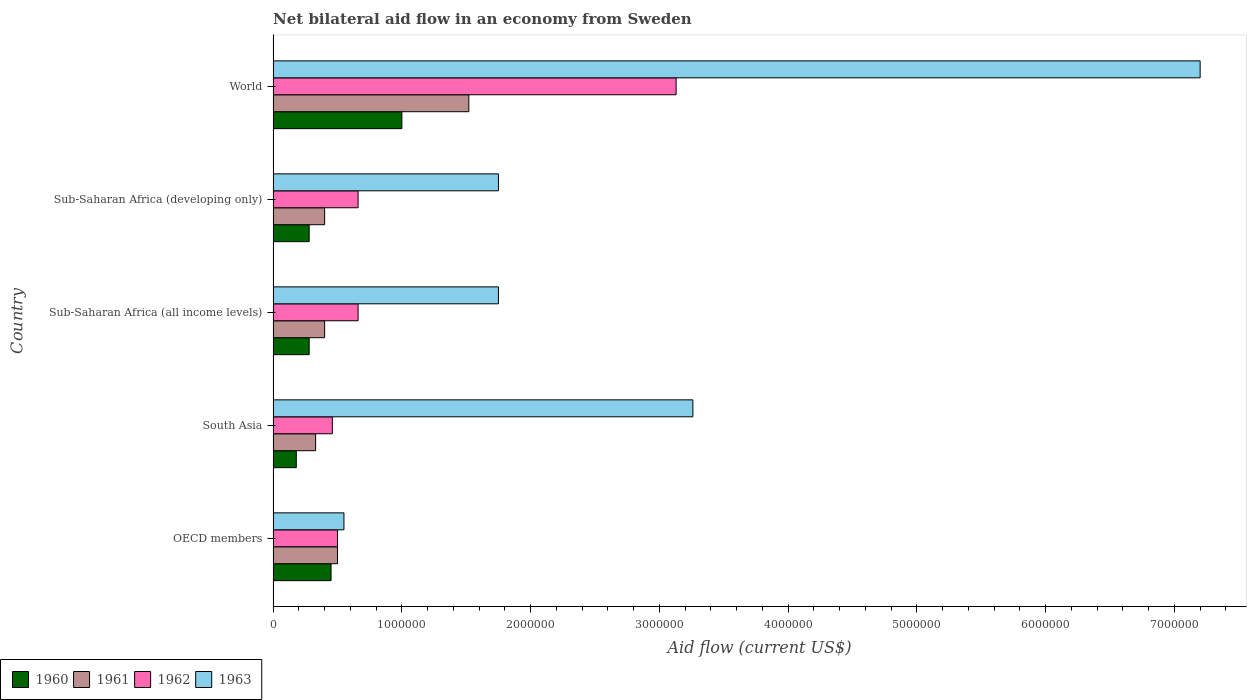How many bars are there on the 1st tick from the bottom?
Ensure brevity in your answer.  4. What is the net bilateral aid flow in 1960 in World?
Give a very brief answer. 1.00e+06. What is the total net bilateral aid flow in 1961 in the graph?
Your response must be concise. 3.15e+06. What is the difference between the net bilateral aid flow in 1962 in Sub-Saharan Africa (all income levels) and that in World?
Your answer should be compact. -2.47e+06. What is the difference between the net bilateral aid flow in 1962 in Sub-Saharan Africa (all income levels) and the net bilateral aid flow in 1963 in OECD members?
Your answer should be very brief. 1.10e+05. What is the average net bilateral aid flow in 1962 per country?
Give a very brief answer. 1.08e+06. What is the difference between the net bilateral aid flow in 1962 and net bilateral aid flow in 1960 in World?
Provide a succinct answer. 2.13e+06. In how many countries, is the net bilateral aid flow in 1962 greater than 7200000 US$?
Your response must be concise. 0. What is the ratio of the net bilateral aid flow in 1961 in South Asia to that in Sub-Saharan Africa (all income levels)?
Ensure brevity in your answer.  0.82. Is the net bilateral aid flow in 1961 in Sub-Saharan Africa (all income levels) less than that in Sub-Saharan Africa (developing only)?
Your answer should be compact. No. What is the difference between the highest and the second highest net bilateral aid flow in 1963?
Your response must be concise. 3.94e+06. What is the difference between the highest and the lowest net bilateral aid flow in 1960?
Ensure brevity in your answer.  8.20e+05. In how many countries, is the net bilateral aid flow in 1963 greater than the average net bilateral aid flow in 1963 taken over all countries?
Your answer should be very brief. 2. Is the sum of the net bilateral aid flow in 1961 in Sub-Saharan Africa (all income levels) and Sub-Saharan Africa (developing only) greater than the maximum net bilateral aid flow in 1962 across all countries?
Your answer should be compact. No. Is it the case that in every country, the sum of the net bilateral aid flow in 1961 and net bilateral aid flow in 1960 is greater than the net bilateral aid flow in 1963?
Provide a short and direct response. No. How many bars are there?
Keep it short and to the point. 20. What is the difference between two consecutive major ticks on the X-axis?
Make the answer very short. 1.00e+06. Are the values on the major ticks of X-axis written in scientific E-notation?
Offer a terse response. No. Does the graph contain any zero values?
Your response must be concise. No. Does the graph contain grids?
Provide a succinct answer. No. Where does the legend appear in the graph?
Your answer should be very brief. Bottom left. How many legend labels are there?
Keep it short and to the point. 4. What is the title of the graph?
Ensure brevity in your answer.  Net bilateral aid flow in an economy from Sweden. What is the Aid flow (current US$) in 1961 in OECD members?
Offer a terse response. 5.00e+05. What is the Aid flow (current US$) in 1962 in OECD members?
Make the answer very short. 5.00e+05. What is the Aid flow (current US$) in 1963 in South Asia?
Make the answer very short. 3.26e+06. What is the Aid flow (current US$) of 1960 in Sub-Saharan Africa (all income levels)?
Offer a very short reply. 2.80e+05. What is the Aid flow (current US$) in 1961 in Sub-Saharan Africa (all income levels)?
Ensure brevity in your answer.  4.00e+05. What is the Aid flow (current US$) in 1962 in Sub-Saharan Africa (all income levels)?
Make the answer very short. 6.60e+05. What is the Aid flow (current US$) of 1963 in Sub-Saharan Africa (all income levels)?
Make the answer very short. 1.75e+06. What is the Aid flow (current US$) of 1961 in Sub-Saharan Africa (developing only)?
Offer a very short reply. 4.00e+05. What is the Aid flow (current US$) of 1963 in Sub-Saharan Africa (developing only)?
Keep it short and to the point. 1.75e+06. What is the Aid flow (current US$) of 1961 in World?
Your answer should be very brief. 1.52e+06. What is the Aid flow (current US$) in 1962 in World?
Your answer should be compact. 3.13e+06. What is the Aid flow (current US$) in 1963 in World?
Offer a terse response. 7.20e+06. Across all countries, what is the maximum Aid flow (current US$) in 1961?
Your answer should be compact. 1.52e+06. Across all countries, what is the maximum Aid flow (current US$) of 1962?
Make the answer very short. 3.13e+06. Across all countries, what is the maximum Aid flow (current US$) of 1963?
Offer a terse response. 7.20e+06. Across all countries, what is the minimum Aid flow (current US$) in 1961?
Ensure brevity in your answer.  3.30e+05. Across all countries, what is the minimum Aid flow (current US$) of 1962?
Offer a very short reply. 4.60e+05. What is the total Aid flow (current US$) in 1960 in the graph?
Make the answer very short. 2.19e+06. What is the total Aid flow (current US$) in 1961 in the graph?
Provide a short and direct response. 3.15e+06. What is the total Aid flow (current US$) in 1962 in the graph?
Your answer should be very brief. 5.41e+06. What is the total Aid flow (current US$) in 1963 in the graph?
Make the answer very short. 1.45e+07. What is the difference between the Aid flow (current US$) of 1960 in OECD members and that in South Asia?
Your answer should be compact. 2.70e+05. What is the difference between the Aid flow (current US$) in 1963 in OECD members and that in South Asia?
Your answer should be compact. -2.71e+06. What is the difference between the Aid flow (current US$) in 1960 in OECD members and that in Sub-Saharan Africa (all income levels)?
Your answer should be compact. 1.70e+05. What is the difference between the Aid flow (current US$) of 1961 in OECD members and that in Sub-Saharan Africa (all income levels)?
Offer a very short reply. 1.00e+05. What is the difference between the Aid flow (current US$) in 1962 in OECD members and that in Sub-Saharan Africa (all income levels)?
Offer a very short reply. -1.60e+05. What is the difference between the Aid flow (current US$) of 1963 in OECD members and that in Sub-Saharan Africa (all income levels)?
Make the answer very short. -1.20e+06. What is the difference between the Aid flow (current US$) in 1963 in OECD members and that in Sub-Saharan Africa (developing only)?
Ensure brevity in your answer.  -1.20e+06. What is the difference between the Aid flow (current US$) in 1960 in OECD members and that in World?
Ensure brevity in your answer.  -5.50e+05. What is the difference between the Aid flow (current US$) in 1961 in OECD members and that in World?
Your answer should be very brief. -1.02e+06. What is the difference between the Aid flow (current US$) of 1962 in OECD members and that in World?
Your answer should be very brief. -2.63e+06. What is the difference between the Aid flow (current US$) in 1963 in OECD members and that in World?
Provide a succinct answer. -6.65e+06. What is the difference between the Aid flow (current US$) in 1960 in South Asia and that in Sub-Saharan Africa (all income levels)?
Provide a succinct answer. -1.00e+05. What is the difference between the Aid flow (current US$) of 1962 in South Asia and that in Sub-Saharan Africa (all income levels)?
Keep it short and to the point. -2.00e+05. What is the difference between the Aid flow (current US$) of 1963 in South Asia and that in Sub-Saharan Africa (all income levels)?
Offer a very short reply. 1.51e+06. What is the difference between the Aid flow (current US$) of 1962 in South Asia and that in Sub-Saharan Africa (developing only)?
Ensure brevity in your answer.  -2.00e+05. What is the difference between the Aid flow (current US$) in 1963 in South Asia and that in Sub-Saharan Africa (developing only)?
Ensure brevity in your answer.  1.51e+06. What is the difference between the Aid flow (current US$) in 1960 in South Asia and that in World?
Your answer should be compact. -8.20e+05. What is the difference between the Aid flow (current US$) of 1961 in South Asia and that in World?
Your answer should be compact. -1.19e+06. What is the difference between the Aid flow (current US$) in 1962 in South Asia and that in World?
Your answer should be very brief. -2.67e+06. What is the difference between the Aid flow (current US$) of 1963 in South Asia and that in World?
Offer a terse response. -3.94e+06. What is the difference between the Aid flow (current US$) in 1961 in Sub-Saharan Africa (all income levels) and that in Sub-Saharan Africa (developing only)?
Keep it short and to the point. 0. What is the difference between the Aid flow (current US$) of 1960 in Sub-Saharan Africa (all income levels) and that in World?
Your response must be concise. -7.20e+05. What is the difference between the Aid flow (current US$) in 1961 in Sub-Saharan Africa (all income levels) and that in World?
Provide a succinct answer. -1.12e+06. What is the difference between the Aid flow (current US$) of 1962 in Sub-Saharan Africa (all income levels) and that in World?
Make the answer very short. -2.47e+06. What is the difference between the Aid flow (current US$) of 1963 in Sub-Saharan Africa (all income levels) and that in World?
Your response must be concise. -5.45e+06. What is the difference between the Aid flow (current US$) of 1960 in Sub-Saharan Africa (developing only) and that in World?
Provide a short and direct response. -7.20e+05. What is the difference between the Aid flow (current US$) of 1961 in Sub-Saharan Africa (developing only) and that in World?
Give a very brief answer. -1.12e+06. What is the difference between the Aid flow (current US$) in 1962 in Sub-Saharan Africa (developing only) and that in World?
Provide a succinct answer. -2.47e+06. What is the difference between the Aid flow (current US$) of 1963 in Sub-Saharan Africa (developing only) and that in World?
Provide a short and direct response. -5.45e+06. What is the difference between the Aid flow (current US$) of 1960 in OECD members and the Aid flow (current US$) of 1963 in South Asia?
Ensure brevity in your answer.  -2.81e+06. What is the difference between the Aid flow (current US$) of 1961 in OECD members and the Aid flow (current US$) of 1962 in South Asia?
Keep it short and to the point. 4.00e+04. What is the difference between the Aid flow (current US$) in 1961 in OECD members and the Aid flow (current US$) in 1963 in South Asia?
Give a very brief answer. -2.76e+06. What is the difference between the Aid flow (current US$) in 1962 in OECD members and the Aid flow (current US$) in 1963 in South Asia?
Your answer should be compact. -2.76e+06. What is the difference between the Aid flow (current US$) of 1960 in OECD members and the Aid flow (current US$) of 1961 in Sub-Saharan Africa (all income levels)?
Your answer should be compact. 5.00e+04. What is the difference between the Aid flow (current US$) in 1960 in OECD members and the Aid flow (current US$) in 1962 in Sub-Saharan Africa (all income levels)?
Give a very brief answer. -2.10e+05. What is the difference between the Aid flow (current US$) in 1960 in OECD members and the Aid flow (current US$) in 1963 in Sub-Saharan Africa (all income levels)?
Your answer should be compact. -1.30e+06. What is the difference between the Aid flow (current US$) in 1961 in OECD members and the Aid flow (current US$) in 1963 in Sub-Saharan Africa (all income levels)?
Your answer should be very brief. -1.25e+06. What is the difference between the Aid flow (current US$) in 1962 in OECD members and the Aid flow (current US$) in 1963 in Sub-Saharan Africa (all income levels)?
Your answer should be very brief. -1.25e+06. What is the difference between the Aid flow (current US$) of 1960 in OECD members and the Aid flow (current US$) of 1963 in Sub-Saharan Africa (developing only)?
Keep it short and to the point. -1.30e+06. What is the difference between the Aid flow (current US$) in 1961 in OECD members and the Aid flow (current US$) in 1962 in Sub-Saharan Africa (developing only)?
Provide a short and direct response. -1.60e+05. What is the difference between the Aid flow (current US$) in 1961 in OECD members and the Aid flow (current US$) in 1963 in Sub-Saharan Africa (developing only)?
Make the answer very short. -1.25e+06. What is the difference between the Aid flow (current US$) of 1962 in OECD members and the Aid flow (current US$) of 1963 in Sub-Saharan Africa (developing only)?
Ensure brevity in your answer.  -1.25e+06. What is the difference between the Aid flow (current US$) in 1960 in OECD members and the Aid flow (current US$) in 1961 in World?
Your answer should be compact. -1.07e+06. What is the difference between the Aid flow (current US$) of 1960 in OECD members and the Aid flow (current US$) of 1962 in World?
Offer a terse response. -2.68e+06. What is the difference between the Aid flow (current US$) of 1960 in OECD members and the Aid flow (current US$) of 1963 in World?
Give a very brief answer. -6.75e+06. What is the difference between the Aid flow (current US$) in 1961 in OECD members and the Aid flow (current US$) in 1962 in World?
Keep it short and to the point. -2.63e+06. What is the difference between the Aid flow (current US$) of 1961 in OECD members and the Aid flow (current US$) of 1963 in World?
Ensure brevity in your answer.  -6.70e+06. What is the difference between the Aid flow (current US$) of 1962 in OECD members and the Aid flow (current US$) of 1963 in World?
Your response must be concise. -6.70e+06. What is the difference between the Aid flow (current US$) of 1960 in South Asia and the Aid flow (current US$) of 1962 in Sub-Saharan Africa (all income levels)?
Provide a succinct answer. -4.80e+05. What is the difference between the Aid flow (current US$) of 1960 in South Asia and the Aid flow (current US$) of 1963 in Sub-Saharan Africa (all income levels)?
Your answer should be very brief. -1.57e+06. What is the difference between the Aid flow (current US$) in 1961 in South Asia and the Aid flow (current US$) in 1962 in Sub-Saharan Africa (all income levels)?
Provide a succinct answer. -3.30e+05. What is the difference between the Aid flow (current US$) of 1961 in South Asia and the Aid flow (current US$) of 1963 in Sub-Saharan Africa (all income levels)?
Your answer should be very brief. -1.42e+06. What is the difference between the Aid flow (current US$) in 1962 in South Asia and the Aid flow (current US$) in 1963 in Sub-Saharan Africa (all income levels)?
Offer a terse response. -1.29e+06. What is the difference between the Aid flow (current US$) of 1960 in South Asia and the Aid flow (current US$) of 1962 in Sub-Saharan Africa (developing only)?
Offer a very short reply. -4.80e+05. What is the difference between the Aid flow (current US$) of 1960 in South Asia and the Aid flow (current US$) of 1963 in Sub-Saharan Africa (developing only)?
Ensure brevity in your answer.  -1.57e+06. What is the difference between the Aid flow (current US$) of 1961 in South Asia and the Aid flow (current US$) of 1962 in Sub-Saharan Africa (developing only)?
Provide a succinct answer. -3.30e+05. What is the difference between the Aid flow (current US$) of 1961 in South Asia and the Aid flow (current US$) of 1963 in Sub-Saharan Africa (developing only)?
Offer a terse response. -1.42e+06. What is the difference between the Aid flow (current US$) in 1962 in South Asia and the Aid flow (current US$) in 1963 in Sub-Saharan Africa (developing only)?
Provide a short and direct response. -1.29e+06. What is the difference between the Aid flow (current US$) in 1960 in South Asia and the Aid flow (current US$) in 1961 in World?
Ensure brevity in your answer.  -1.34e+06. What is the difference between the Aid flow (current US$) in 1960 in South Asia and the Aid flow (current US$) in 1962 in World?
Offer a very short reply. -2.95e+06. What is the difference between the Aid flow (current US$) of 1960 in South Asia and the Aid flow (current US$) of 1963 in World?
Offer a terse response. -7.02e+06. What is the difference between the Aid flow (current US$) in 1961 in South Asia and the Aid flow (current US$) in 1962 in World?
Your answer should be compact. -2.80e+06. What is the difference between the Aid flow (current US$) in 1961 in South Asia and the Aid flow (current US$) in 1963 in World?
Ensure brevity in your answer.  -6.87e+06. What is the difference between the Aid flow (current US$) in 1962 in South Asia and the Aid flow (current US$) in 1963 in World?
Your response must be concise. -6.74e+06. What is the difference between the Aid flow (current US$) in 1960 in Sub-Saharan Africa (all income levels) and the Aid flow (current US$) in 1961 in Sub-Saharan Africa (developing only)?
Offer a terse response. -1.20e+05. What is the difference between the Aid flow (current US$) of 1960 in Sub-Saharan Africa (all income levels) and the Aid flow (current US$) of 1962 in Sub-Saharan Africa (developing only)?
Your answer should be very brief. -3.80e+05. What is the difference between the Aid flow (current US$) of 1960 in Sub-Saharan Africa (all income levels) and the Aid flow (current US$) of 1963 in Sub-Saharan Africa (developing only)?
Your response must be concise. -1.47e+06. What is the difference between the Aid flow (current US$) of 1961 in Sub-Saharan Africa (all income levels) and the Aid flow (current US$) of 1963 in Sub-Saharan Africa (developing only)?
Provide a succinct answer. -1.35e+06. What is the difference between the Aid flow (current US$) in 1962 in Sub-Saharan Africa (all income levels) and the Aid flow (current US$) in 1963 in Sub-Saharan Africa (developing only)?
Offer a terse response. -1.09e+06. What is the difference between the Aid flow (current US$) of 1960 in Sub-Saharan Africa (all income levels) and the Aid flow (current US$) of 1961 in World?
Give a very brief answer. -1.24e+06. What is the difference between the Aid flow (current US$) in 1960 in Sub-Saharan Africa (all income levels) and the Aid flow (current US$) in 1962 in World?
Your response must be concise. -2.85e+06. What is the difference between the Aid flow (current US$) of 1960 in Sub-Saharan Africa (all income levels) and the Aid flow (current US$) of 1963 in World?
Give a very brief answer. -6.92e+06. What is the difference between the Aid flow (current US$) of 1961 in Sub-Saharan Africa (all income levels) and the Aid flow (current US$) of 1962 in World?
Ensure brevity in your answer.  -2.73e+06. What is the difference between the Aid flow (current US$) in 1961 in Sub-Saharan Africa (all income levels) and the Aid flow (current US$) in 1963 in World?
Keep it short and to the point. -6.80e+06. What is the difference between the Aid flow (current US$) in 1962 in Sub-Saharan Africa (all income levels) and the Aid flow (current US$) in 1963 in World?
Your answer should be compact. -6.54e+06. What is the difference between the Aid flow (current US$) of 1960 in Sub-Saharan Africa (developing only) and the Aid flow (current US$) of 1961 in World?
Give a very brief answer. -1.24e+06. What is the difference between the Aid flow (current US$) of 1960 in Sub-Saharan Africa (developing only) and the Aid flow (current US$) of 1962 in World?
Offer a very short reply. -2.85e+06. What is the difference between the Aid flow (current US$) in 1960 in Sub-Saharan Africa (developing only) and the Aid flow (current US$) in 1963 in World?
Offer a very short reply. -6.92e+06. What is the difference between the Aid flow (current US$) in 1961 in Sub-Saharan Africa (developing only) and the Aid flow (current US$) in 1962 in World?
Offer a terse response. -2.73e+06. What is the difference between the Aid flow (current US$) in 1961 in Sub-Saharan Africa (developing only) and the Aid flow (current US$) in 1963 in World?
Keep it short and to the point. -6.80e+06. What is the difference between the Aid flow (current US$) in 1962 in Sub-Saharan Africa (developing only) and the Aid flow (current US$) in 1963 in World?
Give a very brief answer. -6.54e+06. What is the average Aid flow (current US$) in 1960 per country?
Keep it short and to the point. 4.38e+05. What is the average Aid flow (current US$) of 1961 per country?
Offer a very short reply. 6.30e+05. What is the average Aid flow (current US$) in 1962 per country?
Your answer should be compact. 1.08e+06. What is the average Aid flow (current US$) in 1963 per country?
Offer a terse response. 2.90e+06. What is the difference between the Aid flow (current US$) of 1960 and Aid flow (current US$) of 1961 in OECD members?
Provide a succinct answer. -5.00e+04. What is the difference between the Aid flow (current US$) of 1960 and Aid flow (current US$) of 1962 in OECD members?
Offer a terse response. -5.00e+04. What is the difference between the Aid flow (current US$) in 1961 and Aid flow (current US$) in 1962 in OECD members?
Provide a succinct answer. 0. What is the difference between the Aid flow (current US$) in 1960 and Aid flow (current US$) in 1961 in South Asia?
Provide a succinct answer. -1.50e+05. What is the difference between the Aid flow (current US$) in 1960 and Aid flow (current US$) in 1962 in South Asia?
Your answer should be compact. -2.80e+05. What is the difference between the Aid flow (current US$) of 1960 and Aid flow (current US$) of 1963 in South Asia?
Your answer should be very brief. -3.08e+06. What is the difference between the Aid flow (current US$) in 1961 and Aid flow (current US$) in 1963 in South Asia?
Provide a short and direct response. -2.93e+06. What is the difference between the Aid flow (current US$) of 1962 and Aid flow (current US$) of 1963 in South Asia?
Your answer should be compact. -2.80e+06. What is the difference between the Aid flow (current US$) in 1960 and Aid flow (current US$) in 1961 in Sub-Saharan Africa (all income levels)?
Keep it short and to the point. -1.20e+05. What is the difference between the Aid flow (current US$) of 1960 and Aid flow (current US$) of 1962 in Sub-Saharan Africa (all income levels)?
Make the answer very short. -3.80e+05. What is the difference between the Aid flow (current US$) in 1960 and Aid flow (current US$) in 1963 in Sub-Saharan Africa (all income levels)?
Your response must be concise. -1.47e+06. What is the difference between the Aid flow (current US$) in 1961 and Aid flow (current US$) in 1963 in Sub-Saharan Africa (all income levels)?
Your response must be concise. -1.35e+06. What is the difference between the Aid flow (current US$) in 1962 and Aid flow (current US$) in 1963 in Sub-Saharan Africa (all income levels)?
Provide a succinct answer. -1.09e+06. What is the difference between the Aid flow (current US$) of 1960 and Aid flow (current US$) of 1962 in Sub-Saharan Africa (developing only)?
Offer a very short reply. -3.80e+05. What is the difference between the Aid flow (current US$) of 1960 and Aid flow (current US$) of 1963 in Sub-Saharan Africa (developing only)?
Your answer should be very brief. -1.47e+06. What is the difference between the Aid flow (current US$) of 1961 and Aid flow (current US$) of 1962 in Sub-Saharan Africa (developing only)?
Make the answer very short. -2.60e+05. What is the difference between the Aid flow (current US$) of 1961 and Aid flow (current US$) of 1963 in Sub-Saharan Africa (developing only)?
Make the answer very short. -1.35e+06. What is the difference between the Aid flow (current US$) of 1962 and Aid flow (current US$) of 1963 in Sub-Saharan Africa (developing only)?
Ensure brevity in your answer.  -1.09e+06. What is the difference between the Aid flow (current US$) in 1960 and Aid flow (current US$) in 1961 in World?
Offer a terse response. -5.20e+05. What is the difference between the Aid flow (current US$) in 1960 and Aid flow (current US$) in 1962 in World?
Give a very brief answer. -2.13e+06. What is the difference between the Aid flow (current US$) in 1960 and Aid flow (current US$) in 1963 in World?
Make the answer very short. -6.20e+06. What is the difference between the Aid flow (current US$) in 1961 and Aid flow (current US$) in 1962 in World?
Your response must be concise. -1.61e+06. What is the difference between the Aid flow (current US$) in 1961 and Aid flow (current US$) in 1963 in World?
Make the answer very short. -5.68e+06. What is the difference between the Aid flow (current US$) of 1962 and Aid flow (current US$) of 1963 in World?
Make the answer very short. -4.07e+06. What is the ratio of the Aid flow (current US$) of 1960 in OECD members to that in South Asia?
Provide a short and direct response. 2.5. What is the ratio of the Aid flow (current US$) in 1961 in OECD members to that in South Asia?
Make the answer very short. 1.52. What is the ratio of the Aid flow (current US$) of 1962 in OECD members to that in South Asia?
Make the answer very short. 1.09. What is the ratio of the Aid flow (current US$) in 1963 in OECD members to that in South Asia?
Keep it short and to the point. 0.17. What is the ratio of the Aid flow (current US$) of 1960 in OECD members to that in Sub-Saharan Africa (all income levels)?
Provide a succinct answer. 1.61. What is the ratio of the Aid flow (current US$) of 1962 in OECD members to that in Sub-Saharan Africa (all income levels)?
Your answer should be compact. 0.76. What is the ratio of the Aid flow (current US$) of 1963 in OECD members to that in Sub-Saharan Africa (all income levels)?
Provide a succinct answer. 0.31. What is the ratio of the Aid flow (current US$) of 1960 in OECD members to that in Sub-Saharan Africa (developing only)?
Keep it short and to the point. 1.61. What is the ratio of the Aid flow (current US$) in 1961 in OECD members to that in Sub-Saharan Africa (developing only)?
Your answer should be very brief. 1.25. What is the ratio of the Aid flow (current US$) in 1962 in OECD members to that in Sub-Saharan Africa (developing only)?
Ensure brevity in your answer.  0.76. What is the ratio of the Aid flow (current US$) of 1963 in OECD members to that in Sub-Saharan Africa (developing only)?
Offer a very short reply. 0.31. What is the ratio of the Aid flow (current US$) in 1960 in OECD members to that in World?
Ensure brevity in your answer.  0.45. What is the ratio of the Aid flow (current US$) in 1961 in OECD members to that in World?
Your answer should be very brief. 0.33. What is the ratio of the Aid flow (current US$) of 1962 in OECD members to that in World?
Your answer should be very brief. 0.16. What is the ratio of the Aid flow (current US$) in 1963 in OECD members to that in World?
Make the answer very short. 0.08. What is the ratio of the Aid flow (current US$) of 1960 in South Asia to that in Sub-Saharan Africa (all income levels)?
Your response must be concise. 0.64. What is the ratio of the Aid flow (current US$) of 1961 in South Asia to that in Sub-Saharan Africa (all income levels)?
Ensure brevity in your answer.  0.82. What is the ratio of the Aid flow (current US$) in 1962 in South Asia to that in Sub-Saharan Africa (all income levels)?
Ensure brevity in your answer.  0.7. What is the ratio of the Aid flow (current US$) in 1963 in South Asia to that in Sub-Saharan Africa (all income levels)?
Provide a short and direct response. 1.86. What is the ratio of the Aid flow (current US$) in 1960 in South Asia to that in Sub-Saharan Africa (developing only)?
Provide a succinct answer. 0.64. What is the ratio of the Aid flow (current US$) of 1961 in South Asia to that in Sub-Saharan Africa (developing only)?
Your response must be concise. 0.82. What is the ratio of the Aid flow (current US$) of 1962 in South Asia to that in Sub-Saharan Africa (developing only)?
Make the answer very short. 0.7. What is the ratio of the Aid flow (current US$) in 1963 in South Asia to that in Sub-Saharan Africa (developing only)?
Offer a terse response. 1.86. What is the ratio of the Aid flow (current US$) in 1960 in South Asia to that in World?
Your response must be concise. 0.18. What is the ratio of the Aid flow (current US$) in 1961 in South Asia to that in World?
Provide a short and direct response. 0.22. What is the ratio of the Aid flow (current US$) of 1962 in South Asia to that in World?
Provide a short and direct response. 0.15. What is the ratio of the Aid flow (current US$) in 1963 in South Asia to that in World?
Make the answer very short. 0.45. What is the ratio of the Aid flow (current US$) in 1960 in Sub-Saharan Africa (all income levels) to that in World?
Provide a succinct answer. 0.28. What is the ratio of the Aid flow (current US$) of 1961 in Sub-Saharan Africa (all income levels) to that in World?
Offer a terse response. 0.26. What is the ratio of the Aid flow (current US$) of 1962 in Sub-Saharan Africa (all income levels) to that in World?
Make the answer very short. 0.21. What is the ratio of the Aid flow (current US$) of 1963 in Sub-Saharan Africa (all income levels) to that in World?
Give a very brief answer. 0.24. What is the ratio of the Aid flow (current US$) of 1960 in Sub-Saharan Africa (developing only) to that in World?
Ensure brevity in your answer.  0.28. What is the ratio of the Aid flow (current US$) of 1961 in Sub-Saharan Africa (developing only) to that in World?
Your answer should be compact. 0.26. What is the ratio of the Aid flow (current US$) of 1962 in Sub-Saharan Africa (developing only) to that in World?
Make the answer very short. 0.21. What is the ratio of the Aid flow (current US$) of 1963 in Sub-Saharan Africa (developing only) to that in World?
Provide a succinct answer. 0.24. What is the difference between the highest and the second highest Aid flow (current US$) in 1961?
Give a very brief answer. 1.02e+06. What is the difference between the highest and the second highest Aid flow (current US$) of 1962?
Your response must be concise. 2.47e+06. What is the difference between the highest and the second highest Aid flow (current US$) in 1963?
Your answer should be very brief. 3.94e+06. What is the difference between the highest and the lowest Aid flow (current US$) of 1960?
Offer a terse response. 8.20e+05. What is the difference between the highest and the lowest Aid flow (current US$) of 1961?
Give a very brief answer. 1.19e+06. What is the difference between the highest and the lowest Aid flow (current US$) of 1962?
Provide a succinct answer. 2.67e+06. What is the difference between the highest and the lowest Aid flow (current US$) in 1963?
Your response must be concise. 6.65e+06. 